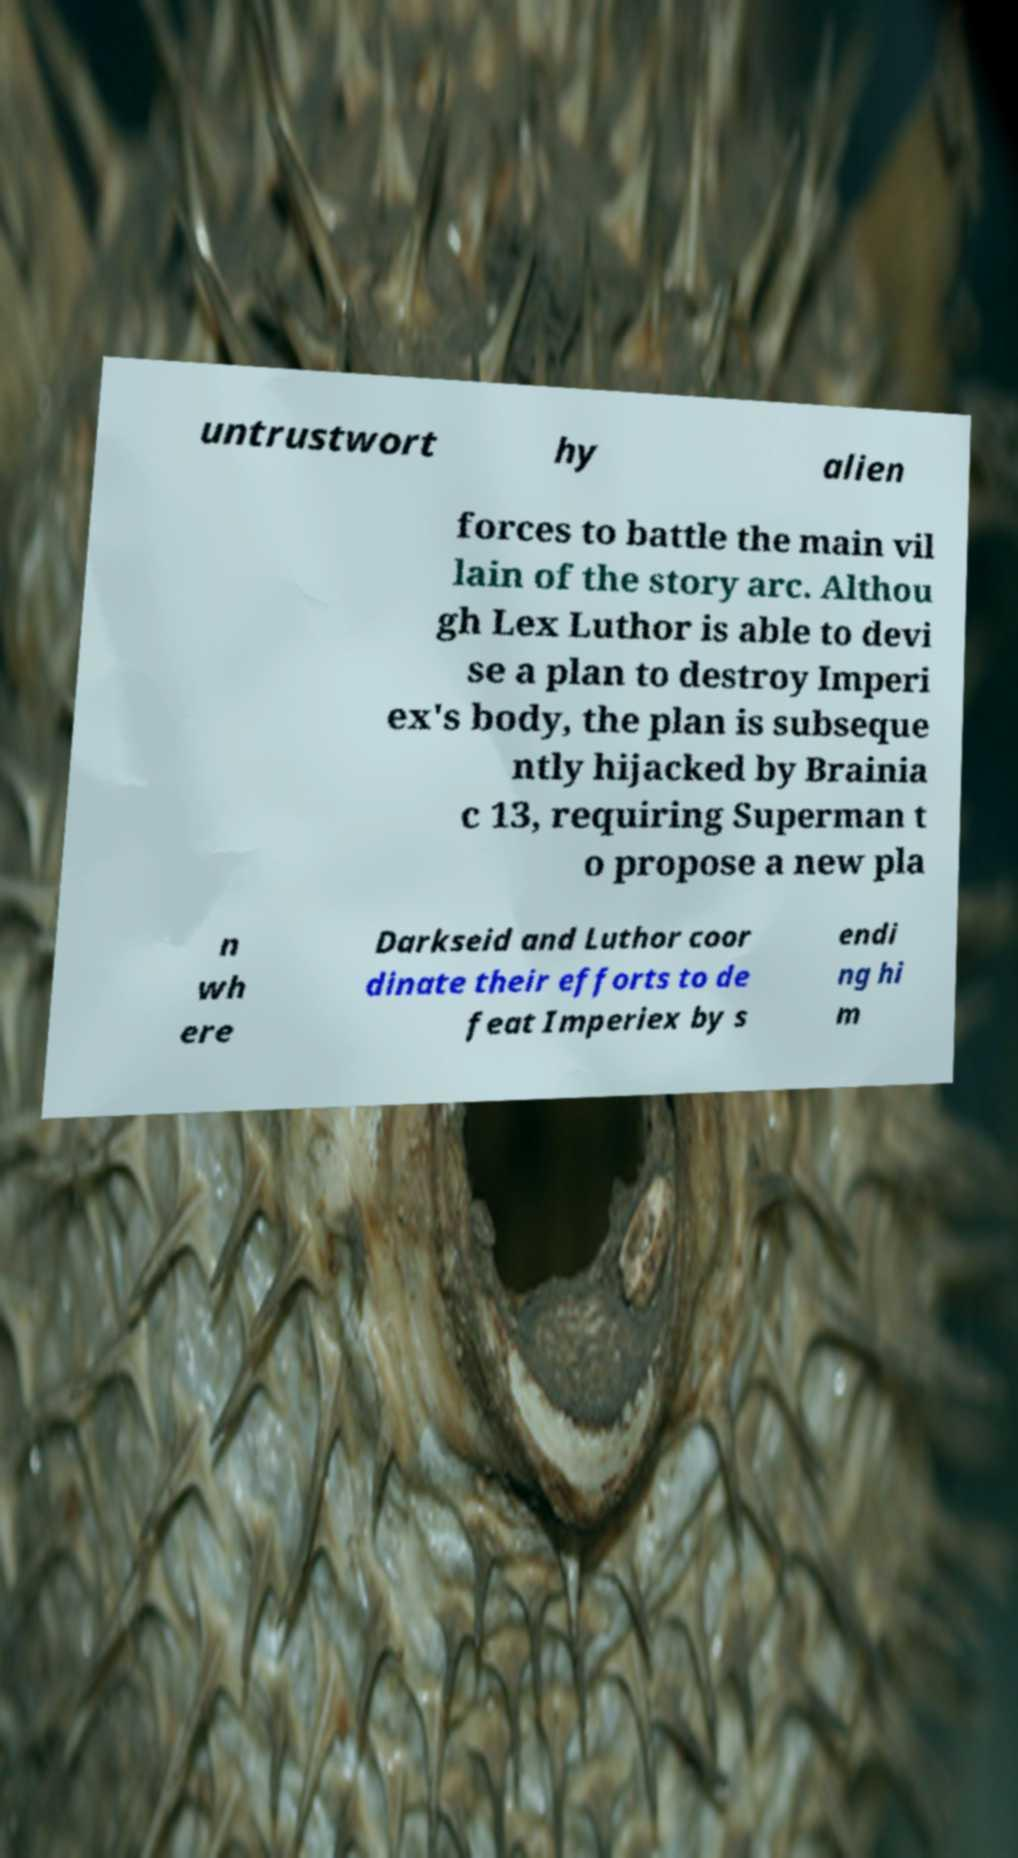Could you extract and type out the text from this image? untrustwort hy alien forces to battle the main vil lain of the story arc. Althou gh Lex Luthor is able to devi se a plan to destroy Imperi ex's body, the plan is subseque ntly hijacked by Brainia c 13, requiring Superman t o propose a new pla n wh ere Darkseid and Luthor coor dinate their efforts to de feat Imperiex by s endi ng hi m 